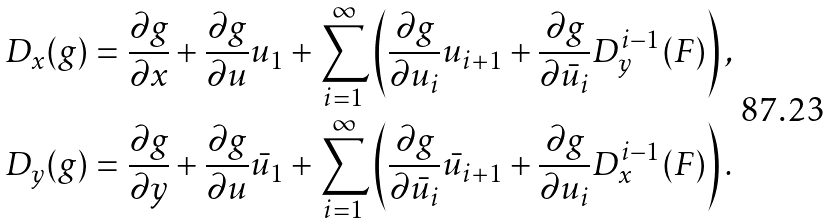<formula> <loc_0><loc_0><loc_500><loc_500>D _ { x } ( g ) = \frac { \partial g } { \partial x } + \frac { \partial g } { \partial u } u _ { 1 } + \sum ^ { \infty } _ { i = 1 } \left ( \frac { \partial g } { \partial u _ { i } } u _ { i + 1 } + \frac { \partial g } { \partial \bar { u } _ { i } } D ^ { i - 1 } _ { y } ( F ) \right ) , \\ D _ { y } ( g ) = \frac { \partial g } { \partial y } + \frac { \partial g } { \partial u } \bar { u } _ { 1 } + \sum ^ { \infty } _ { i = 1 } \left ( \frac { \partial g } { \partial \bar { u } _ { i } } \bar { u } _ { i + 1 } + \frac { \partial g } { \partial u _ { i } } D ^ { i - 1 } _ { x } ( F ) \right ) .</formula> 